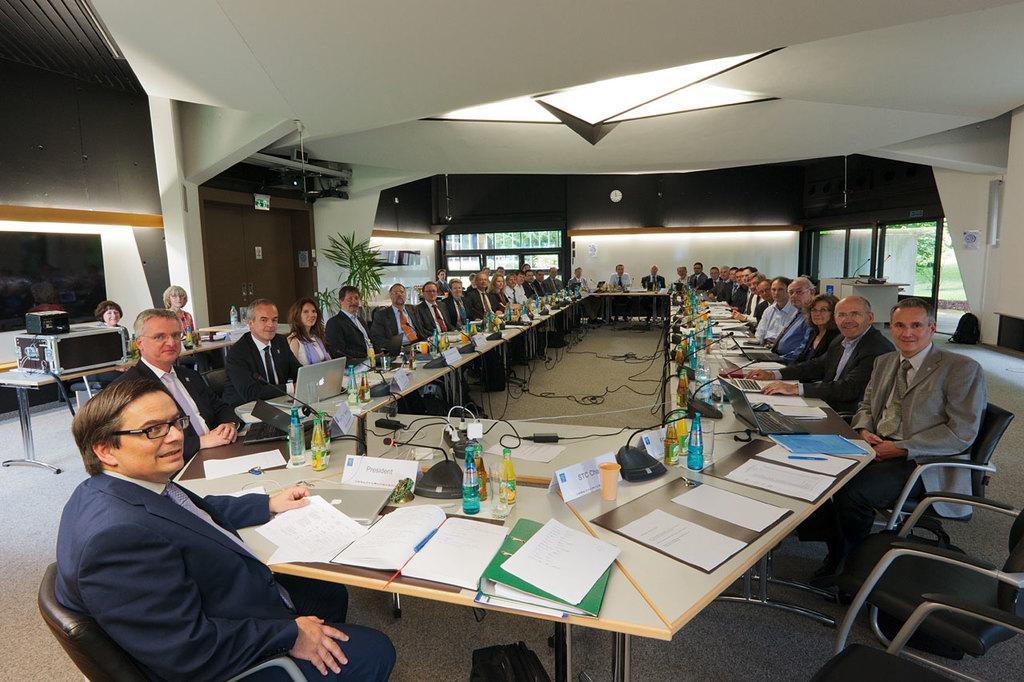Describe this image in one or two sentences. As we can see in the image there is a color wall, few people sitting on chairs and there is a table. On table there is are books, files, papers, bottles, mics and glasses. 